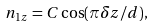Convert formula to latex. <formula><loc_0><loc_0><loc_500><loc_500>n _ { 1 z } = C \cos ( \pi \delta z / d ) ,</formula> 